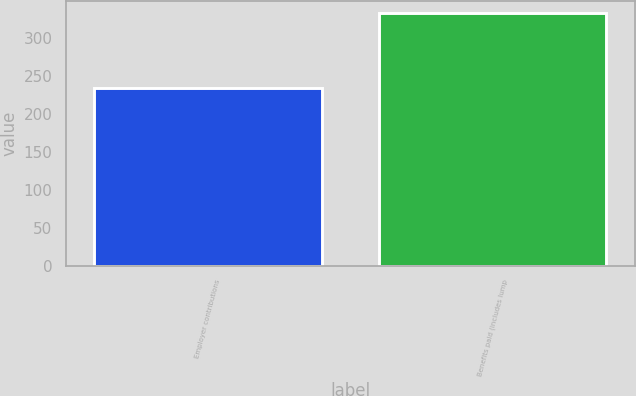<chart> <loc_0><loc_0><loc_500><loc_500><bar_chart><fcel>Employer contributions<fcel>Benefits paid (includes lump<nl><fcel>233<fcel>332<nl></chart> 